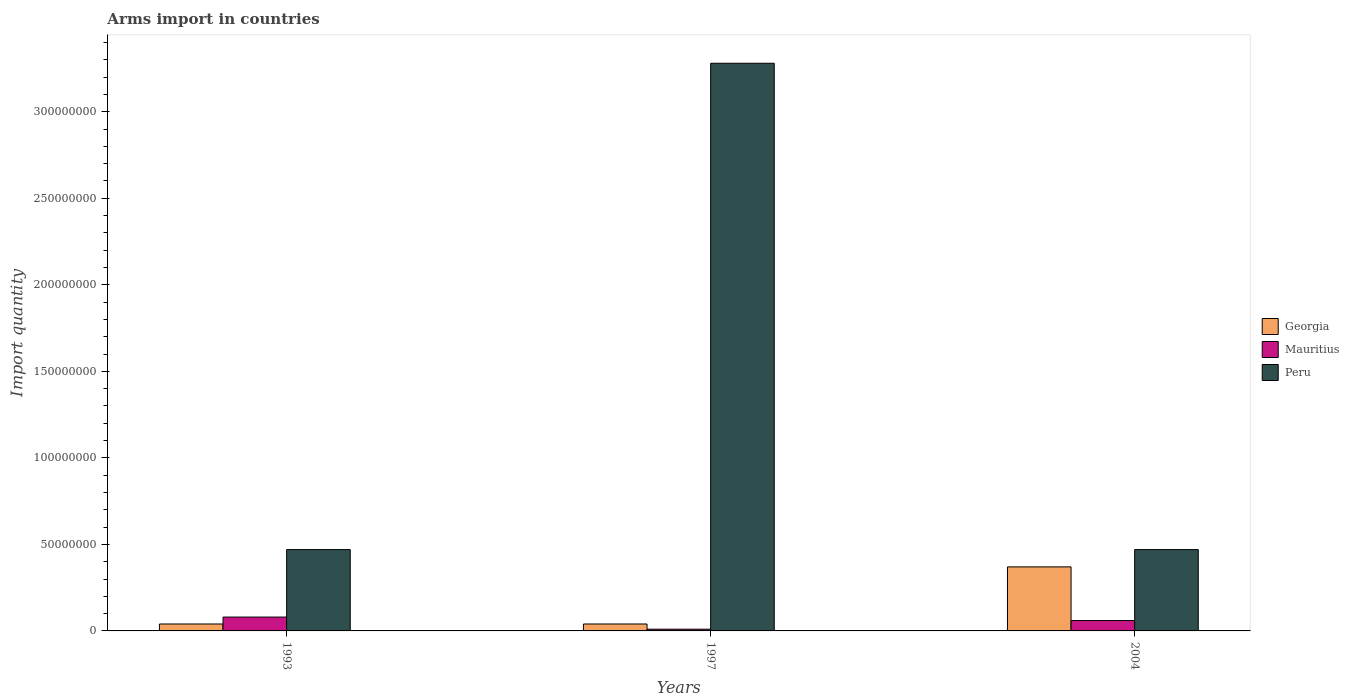Are the number of bars per tick equal to the number of legend labels?
Ensure brevity in your answer.  Yes. Are the number of bars on each tick of the X-axis equal?
Your answer should be very brief. Yes. How many bars are there on the 3rd tick from the right?
Keep it short and to the point. 3. Across all years, what is the maximum total arms import in Georgia?
Ensure brevity in your answer.  3.70e+07. In which year was the total arms import in Mauritius maximum?
Provide a short and direct response. 1993. In which year was the total arms import in Peru minimum?
Your answer should be compact. 1993. What is the total total arms import in Mauritius in the graph?
Provide a succinct answer. 1.50e+07. What is the difference between the total arms import in Peru in 1993 and that in 2004?
Your response must be concise. 0. What is the difference between the total arms import in Peru in 1993 and the total arms import in Mauritius in 2004?
Your response must be concise. 4.10e+07. What is the average total arms import in Mauritius per year?
Offer a very short reply. 5.00e+06. In the year 1993, what is the difference between the total arms import in Peru and total arms import in Mauritius?
Ensure brevity in your answer.  3.90e+07. What is the ratio of the total arms import in Mauritius in 1997 to that in 2004?
Provide a short and direct response. 0.17. Is the total arms import in Peru in 1993 less than that in 1997?
Your answer should be compact. Yes. What is the difference between the highest and the second highest total arms import in Georgia?
Your answer should be compact. 3.30e+07. What is the difference between the highest and the lowest total arms import in Mauritius?
Make the answer very short. 7.00e+06. What does the 1st bar from the left in 1997 represents?
Your response must be concise. Georgia. What does the 2nd bar from the right in 2004 represents?
Offer a very short reply. Mauritius. Is it the case that in every year, the sum of the total arms import in Georgia and total arms import in Mauritius is greater than the total arms import in Peru?
Make the answer very short. No. How many bars are there?
Offer a terse response. 9. Are all the bars in the graph horizontal?
Ensure brevity in your answer.  No. How many years are there in the graph?
Your response must be concise. 3. What is the difference between two consecutive major ticks on the Y-axis?
Offer a terse response. 5.00e+07. Are the values on the major ticks of Y-axis written in scientific E-notation?
Make the answer very short. No. Does the graph contain grids?
Offer a terse response. No. What is the title of the graph?
Ensure brevity in your answer.  Arms import in countries. Does "Ukraine" appear as one of the legend labels in the graph?
Make the answer very short. No. What is the label or title of the X-axis?
Your response must be concise. Years. What is the label or title of the Y-axis?
Your answer should be compact. Import quantity. What is the Import quantity in Peru in 1993?
Make the answer very short. 4.70e+07. What is the Import quantity in Georgia in 1997?
Offer a very short reply. 4.00e+06. What is the Import quantity in Mauritius in 1997?
Provide a short and direct response. 1.00e+06. What is the Import quantity of Peru in 1997?
Your response must be concise. 3.28e+08. What is the Import quantity of Georgia in 2004?
Offer a very short reply. 3.70e+07. What is the Import quantity of Peru in 2004?
Your answer should be compact. 4.70e+07. Across all years, what is the maximum Import quantity in Georgia?
Your answer should be compact. 3.70e+07. Across all years, what is the maximum Import quantity in Mauritius?
Your response must be concise. 8.00e+06. Across all years, what is the maximum Import quantity of Peru?
Your answer should be very brief. 3.28e+08. Across all years, what is the minimum Import quantity in Georgia?
Offer a very short reply. 4.00e+06. Across all years, what is the minimum Import quantity of Mauritius?
Make the answer very short. 1.00e+06. Across all years, what is the minimum Import quantity in Peru?
Provide a succinct answer. 4.70e+07. What is the total Import quantity in Georgia in the graph?
Make the answer very short. 4.50e+07. What is the total Import quantity of Mauritius in the graph?
Ensure brevity in your answer.  1.50e+07. What is the total Import quantity in Peru in the graph?
Your response must be concise. 4.22e+08. What is the difference between the Import quantity in Georgia in 1993 and that in 1997?
Ensure brevity in your answer.  0. What is the difference between the Import quantity in Mauritius in 1993 and that in 1997?
Keep it short and to the point. 7.00e+06. What is the difference between the Import quantity of Peru in 1993 and that in 1997?
Your answer should be very brief. -2.81e+08. What is the difference between the Import quantity in Georgia in 1993 and that in 2004?
Your answer should be very brief. -3.30e+07. What is the difference between the Import quantity of Mauritius in 1993 and that in 2004?
Offer a terse response. 2.00e+06. What is the difference between the Import quantity in Georgia in 1997 and that in 2004?
Your response must be concise. -3.30e+07. What is the difference between the Import quantity in Mauritius in 1997 and that in 2004?
Keep it short and to the point. -5.00e+06. What is the difference between the Import quantity in Peru in 1997 and that in 2004?
Make the answer very short. 2.81e+08. What is the difference between the Import quantity of Georgia in 1993 and the Import quantity of Peru in 1997?
Provide a short and direct response. -3.24e+08. What is the difference between the Import quantity in Mauritius in 1993 and the Import quantity in Peru in 1997?
Your answer should be very brief. -3.20e+08. What is the difference between the Import quantity of Georgia in 1993 and the Import quantity of Mauritius in 2004?
Your answer should be compact. -2.00e+06. What is the difference between the Import quantity in Georgia in 1993 and the Import quantity in Peru in 2004?
Offer a terse response. -4.30e+07. What is the difference between the Import quantity of Mauritius in 1993 and the Import quantity of Peru in 2004?
Ensure brevity in your answer.  -3.90e+07. What is the difference between the Import quantity in Georgia in 1997 and the Import quantity in Mauritius in 2004?
Your answer should be compact. -2.00e+06. What is the difference between the Import quantity of Georgia in 1997 and the Import quantity of Peru in 2004?
Your response must be concise. -4.30e+07. What is the difference between the Import quantity in Mauritius in 1997 and the Import quantity in Peru in 2004?
Offer a terse response. -4.60e+07. What is the average Import quantity in Georgia per year?
Provide a short and direct response. 1.50e+07. What is the average Import quantity in Mauritius per year?
Offer a very short reply. 5.00e+06. What is the average Import quantity in Peru per year?
Give a very brief answer. 1.41e+08. In the year 1993, what is the difference between the Import quantity of Georgia and Import quantity of Mauritius?
Your answer should be compact. -4.00e+06. In the year 1993, what is the difference between the Import quantity in Georgia and Import quantity in Peru?
Offer a very short reply. -4.30e+07. In the year 1993, what is the difference between the Import quantity in Mauritius and Import quantity in Peru?
Offer a terse response. -3.90e+07. In the year 1997, what is the difference between the Import quantity in Georgia and Import quantity in Peru?
Make the answer very short. -3.24e+08. In the year 1997, what is the difference between the Import quantity in Mauritius and Import quantity in Peru?
Your answer should be compact. -3.27e+08. In the year 2004, what is the difference between the Import quantity in Georgia and Import quantity in Mauritius?
Offer a very short reply. 3.10e+07. In the year 2004, what is the difference between the Import quantity in Georgia and Import quantity in Peru?
Keep it short and to the point. -1.00e+07. In the year 2004, what is the difference between the Import quantity in Mauritius and Import quantity in Peru?
Offer a very short reply. -4.10e+07. What is the ratio of the Import quantity of Peru in 1993 to that in 1997?
Make the answer very short. 0.14. What is the ratio of the Import quantity of Georgia in 1993 to that in 2004?
Keep it short and to the point. 0.11. What is the ratio of the Import quantity in Peru in 1993 to that in 2004?
Your answer should be compact. 1. What is the ratio of the Import quantity of Georgia in 1997 to that in 2004?
Your answer should be very brief. 0.11. What is the ratio of the Import quantity in Mauritius in 1997 to that in 2004?
Your answer should be very brief. 0.17. What is the ratio of the Import quantity in Peru in 1997 to that in 2004?
Your answer should be very brief. 6.98. What is the difference between the highest and the second highest Import quantity in Georgia?
Give a very brief answer. 3.30e+07. What is the difference between the highest and the second highest Import quantity of Mauritius?
Your response must be concise. 2.00e+06. What is the difference between the highest and the second highest Import quantity in Peru?
Your answer should be very brief. 2.81e+08. What is the difference between the highest and the lowest Import quantity of Georgia?
Provide a succinct answer. 3.30e+07. What is the difference between the highest and the lowest Import quantity of Peru?
Your answer should be very brief. 2.81e+08. 